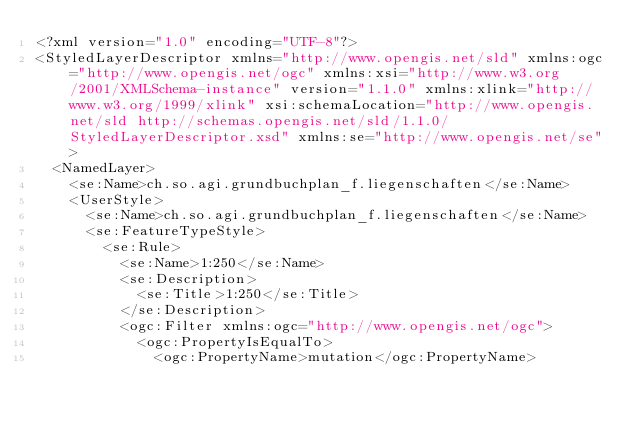<code> <loc_0><loc_0><loc_500><loc_500><_Scheme_><?xml version="1.0" encoding="UTF-8"?>
<StyledLayerDescriptor xmlns="http://www.opengis.net/sld" xmlns:ogc="http://www.opengis.net/ogc" xmlns:xsi="http://www.w3.org/2001/XMLSchema-instance" version="1.1.0" xmlns:xlink="http://www.w3.org/1999/xlink" xsi:schemaLocation="http://www.opengis.net/sld http://schemas.opengis.net/sld/1.1.0/StyledLayerDescriptor.xsd" xmlns:se="http://www.opengis.net/se">
  <NamedLayer>
    <se:Name>ch.so.agi.grundbuchplan_f.liegenschaften</se:Name>
    <UserStyle>
      <se:Name>ch.so.agi.grundbuchplan_f.liegenschaften</se:Name>
      <se:FeatureTypeStyle>
        <se:Rule>
          <se:Name>1:250</se:Name>
          <se:Description>
            <se:Title>1:250</se:Title>
          </se:Description>
          <ogc:Filter xmlns:ogc="http://www.opengis.net/ogc">
            <ogc:PropertyIsEqualTo>
              <ogc:PropertyName>mutation</ogc:PropertyName></code> 